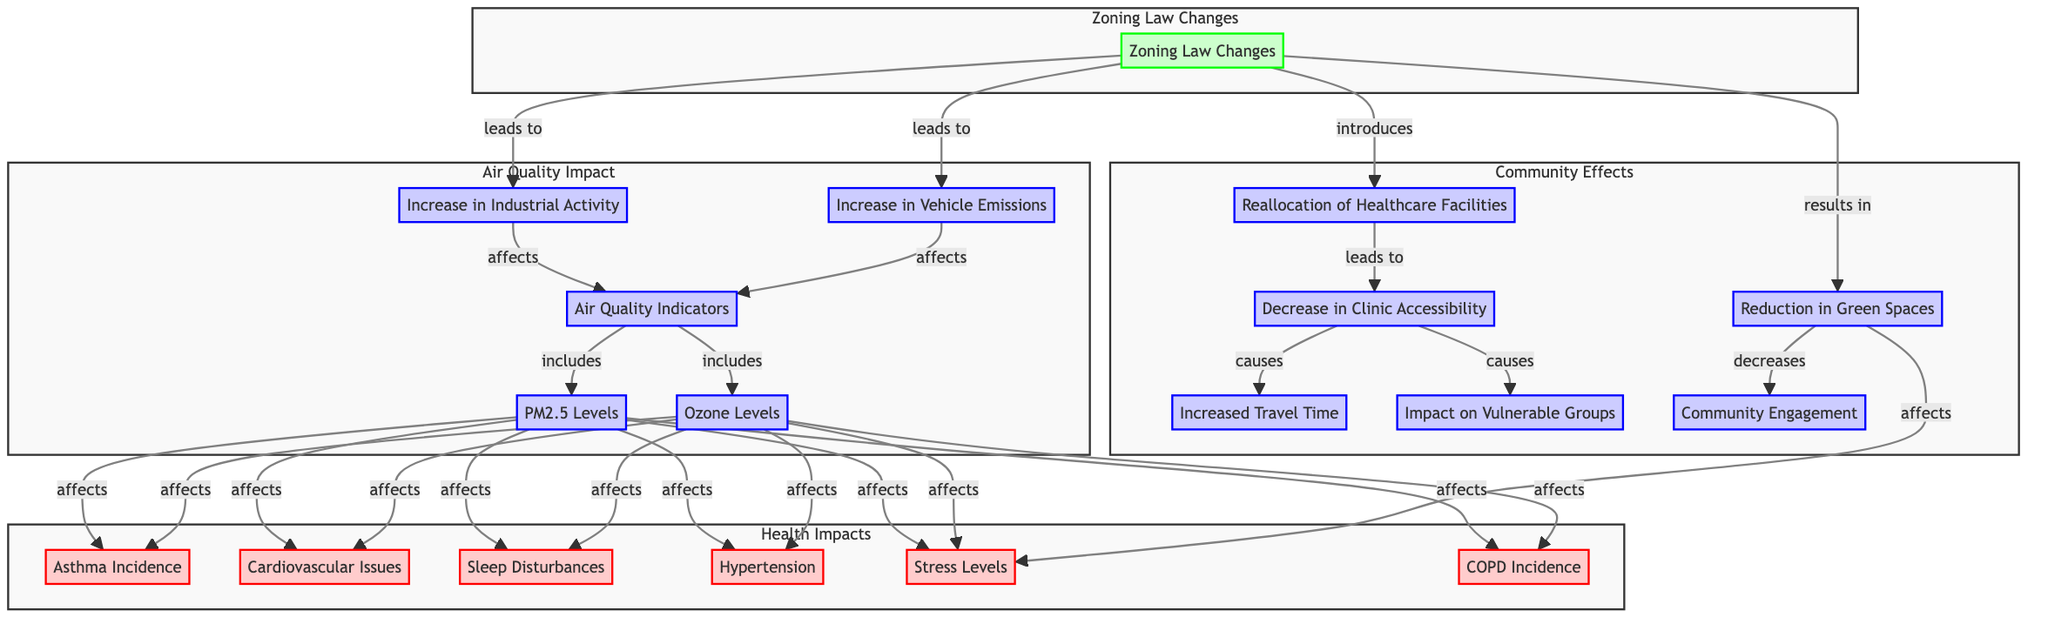What are the two main causes of air quality indicator changes? The diagram shows that the two main causes of air quality indicator changes are "Increase in Industrial Activity" and "Increase in Vehicle Emissions."
Answer: Increase in Industrial Activity and Increase in Vehicle Emissions How many health impacts are indicated in the diagram? By counting the health impact nodes labeled in the Health Impacts subgraph, we see there are six health impacts listed: Asthma Incidence, Cardiovascular Issues, Sleep Disturbances, Hypertension, Stress Levels, and COPD Incidence.
Answer: 6 What is the effect of decreased clinic accessibility? The diagram shows that decreased clinic accessibility causes increased travel time and affects vulnerable groups as direct effects.
Answer: Increased Travel Time and Impact on Vulnerable Groups Which environmental aspect is directly affected by zoning law changes according to the diagram? The diagram indicates that zoning law changes directly lead to "Increase in Industrial Activity" and "Increase in Vehicle Emissions," both of which affect air quality indicators.
Answer: Increase in Industrial Activity and Increase in Vehicle Emissions What health impact is related to the reduction in green spaces? The diagram connects the reduction in green spaces to an increase in stress levels, suggesting it has a direct effect on this health impact.
Answer: Stress Levels How many community effects are listed in the diagram? In the Community Effects subgraph, there are six listed effects: Reallocation of Healthcare Facilities, Decrease in Clinic Accessibility, Increased Travel Time, Impact on Vulnerable Groups, Reduction in Green Spaces, and Community Engagement, making a total of six.
Answer: 6 Which health condition is influenced by PM2.5 levels? The diagram shows a direct relationship where both "Asthma Incidence" and "Cardiovascular Issues" are explicitly affected by PM2.5 levels.
Answer: Asthma Incidence and Cardiovascular Issues What is the consequence of zoning law changes leading to an increase in emissions? The diagram indicates that zoning law changes leading to an increase in emissions subsequently affects air quality indicators, which then influence various health impacts.
Answer: Affects Air Quality Indicators Which group is particularly highlighted as being affected by zoning law changes? The "Impact on Vulnerable Groups" is explicitly mentioned in the diagram as an effect of decreased clinic accessibility and zoning law changes, highlighting their particular concern.
Answer: Vulnerable Groups 